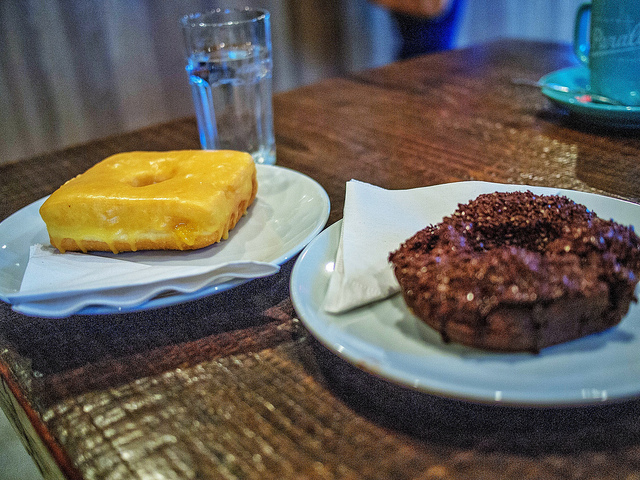What kind of beverages might pair well with these donuts? A cup of freshly brewed coffee or a glass of cold milk would complement the sweet flavors of these donuts wonderfully. 